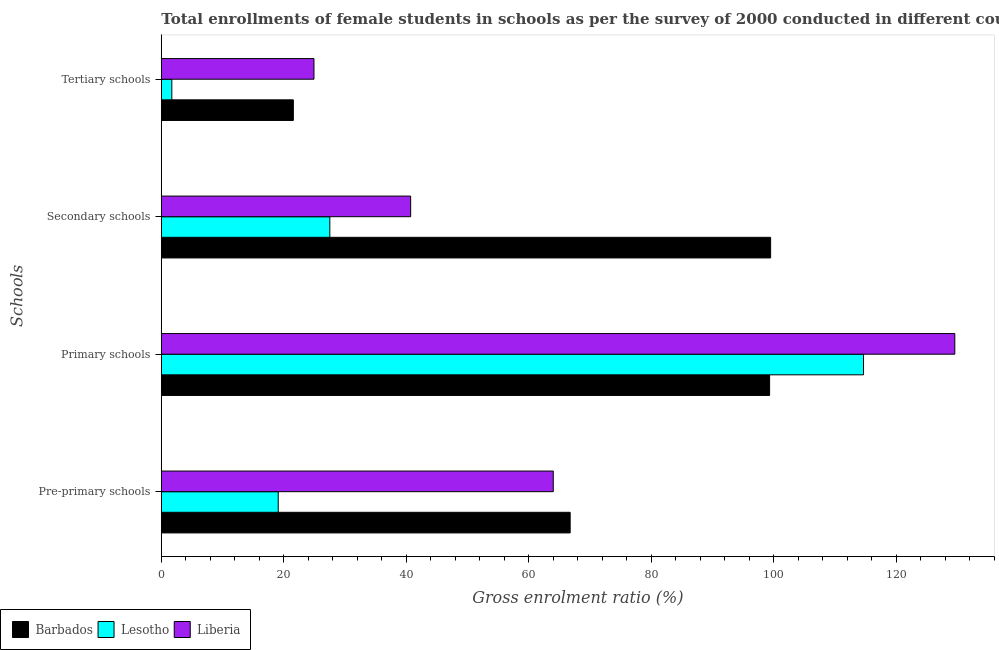How many groups of bars are there?
Make the answer very short. 4. Are the number of bars per tick equal to the number of legend labels?
Keep it short and to the point. Yes. How many bars are there on the 4th tick from the top?
Your answer should be compact. 3. How many bars are there on the 2nd tick from the bottom?
Your answer should be compact. 3. What is the label of the 2nd group of bars from the top?
Give a very brief answer. Secondary schools. What is the gross enrolment ratio(female) in primary schools in Lesotho?
Ensure brevity in your answer.  114.68. Across all countries, what is the maximum gross enrolment ratio(female) in primary schools?
Provide a short and direct response. 129.6. Across all countries, what is the minimum gross enrolment ratio(female) in primary schools?
Provide a succinct answer. 99.35. In which country was the gross enrolment ratio(female) in primary schools maximum?
Ensure brevity in your answer.  Liberia. In which country was the gross enrolment ratio(female) in secondary schools minimum?
Your answer should be very brief. Lesotho. What is the total gross enrolment ratio(female) in tertiary schools in the graph?
Your response must be concise. 48.21. What is the difference between the gross enrolment ratio(female) in secondary schools in Lesotho and that in Barbados?
Offer a terse response. -71.99. What is the difference between the gross enrolment ratio(female) in tertiary schools in Barbados and the gross enrolment ratio(female) in pre-primary schools in Liberia?
Provide a succinct answer. -42.45. What is the average gross enrolment ratio(female) in tertiary schools per country?
Your response must be concise. 16.07. What is the difference between the gross enrolment ratio(female) in pre-primary schools and gross enrolment ratio(female) in primary schools in Barbados?
Offer a terse response. -32.58. What is the ratio of the gross enrolment ratio(female) in secondary schools in Barbados to that in Lesotho?
Offer a terse response. 3.62. What is the difference between the highest and the second highest gross enrolment ratio(female) in primary schools?
Ensure brevity in your answer.  14.91. What is the difference between the highest and the lowest gross enrolment ratio(female) in secondary schools?
Your response must be concise. 71.99. In how many countries, is the gross enrolment ratio(female) in tertiary schools greater than the average gross enrolment ratio(female) in tertiary schools taken over all countries?
Give a very brief answer. 2. What does the 2nd bar from the top in Tertiary schools represents?
Offer a terse response. Lesotho. What does the 2nd bar from the bottom in Secondary schools represents?
Your answer should be compact. Lesotho. What is the difference between two consecutive major ticks on the X-axis?
Provide a succinct answer. 20. Are the values on the major ticks of X-axis written in scientific E-notation?
Keep it short and to the point. No. Does the graph contain any zero values?
Your response must be concise. No. What is the title of the graph?
Offer a terse response. Total enrollments of female students in schools as per the survey of 2000 conducted in different countries. Does "Luxembourg" appear as one of the legend labels in the graph?
Offer a very short reply. No. What is the label or title of the Y-axis?
Offer a terse response. Schools. What is the Gross enrolment ratio (%) in Barbados in Pre-primary schools?
Make the answer very short. 66.77. What is the Gross enrolment ratio (%) of Lesotho in Pre-primary schools?
Offer a very short reply. 19.09. What is the Gross enrolment ratio (%) in Liberia in Pre-primary schools?
Provide a succinct answer. 64.01. What is the Gross enrolment ratio (%) of Barbados in Primary schools?
Provide a short and direct response. 99.35. What is the Gross enrolment ratio (%) of Lesotho in Primary schools?
Offer a very short reply. 114.68. What is the Gross enrolment ratio (%) in Liberia in Primary schools?
Offer a very short reply. 129.6. What is the Gross enrolment ratio (%) in Barbados in Secondary schools?
Offer a very short reply. 99.51. What is the Gross enrolment ratio (%) of Lesotho in Secondary schools?
Keep it short and to the point. 27.52. What is the Gross enrolment ratio (%) of Liberia in Secondary schools?
Offer a terse response. 40.72. What is the Gross enrolment ratio (%) in Barbados in Tertiary schools?
Offer a terse response. 21.56. What is the Gross enrolment ratio (%) of Lesotho in Tertiary schools?
Give a very brief answer. 1.72. What is the Gross enrolment ratio (%) in Liberia in Tertiary schools?
Your response must be concise. 24.93. Across all Schools, what is the maximum Gross enrolment ratio (%) in Barbados?
Keep it short and to the point. 99.51. Across all Schools, what is the maximum Gross enrolment ratio (%) in Lesotho?
Your response must be concise. 114.68. Across all Schools, what is the maximum Gross enrolment ratio (%) of Liberia?
Provide a short and direct response. 129.6. Across all Schools, what is the minimum Gross enrolment ratio (%) in Barbados?
Ensure brevity in your answer.  21.56. Across all Schools, what is the minimum Gross enrolment ratio (%) of Lesotho?
Offer a terse response. 1.72. Across all Schools, what is the minimum Gross enrolment ratio (%) of Liberia?
Provide a succinct answer. 24.93. What is the total Gross enrolment ratio (%) of Barbados in the graph?
Offer a terse response. 287.2. What is the total Gross enrolment ratio (%) of Lesotho in the graph?
Provide a succinct answer. 163.02. What is the total Gross enrolment ratio (%) in Liberia in the graph?
Make the answer very short. 259.27. What is the difference between the Gross enrolment ratio (%) in Barbados in Pre-primary schools and that in Primary schools?
Give a very brief answer. -32.58. What is the difference between the Gross enrolment ratio (%) of Lesotho in Pre-primary schools and that in Primary schools?
Offer a very short reply. -95.59. What is the difference between the Gross enrolment ratio (%) of Liberia in Pre-primary schools and that in Primary schools?
Provide a short and direct response. -65.58. What is the difference between the Gross enrolment ratio (%) in Barbados in Pre-primary schools and that in Secondary schools?
Offer a very short reply. -32.74. What is the difference between the Gross enrolment ratio (%) of Lesotho in Pre-primary schools and that in Secondary schools?
Your response must be concise. -8.43. What is the difference between the Gross enrolment ratio (%) in Liberia in Pre-primary schools and that in Secondary schools?
Your answer should be compact. 23.29. What is the difference between the Gross enrolment ratio (%) of Barbados in Pre-primary schools and that in Tertiary schools?
Provide a succinct answer. 45.21. What is the difference between the Gross enrolment ratio (%) in Lesotho in Pre-primary schools and that in Tertiary schools?
Your response must be concise. 17.38. What is the difference between the Gross enrolment ratio (%) in Liberia in Pre-primary schools and that in Tertiary schools?
Provide a succinct answer. 39.08. What is the difference between the Gross enrolment ratio (%) in Barbados in Primary schools and that in Secondary schools?
Your answer should be very brief. -0.17. What is the difference between the Gross enrolment ratio (%) of Lesotho in Primary schools and that in Secondary schools?
Your answer should be very brief. 87.16. What is the difference between the Gross enrolment ratio (%) of Liberia in Primary schools and that in Secondary schools?
Keep it short and to the point. 88.87. What is the difference between the Gross enrolment ratio (%) of Barbados in Primary schools and that in Tertiary schools?
Offer a terse response. 77.78. What is the difference between the Gross enrolment ratio (%) of Lesotho in Primary schools and that in Tertiary schools?
Your answer should be very brief. 112.97. What is the difference between the Gross enrolment ratio (%) of Liberia in Primary schools and that in Tertiary schools?
Your answer should be compact. 104.66. What is the difference between the Gross enrolment ratio (%) of Barbados in Secondary schools and that in Tertiary schools?
Provide a short and direct response. 77.95. What is the difference between the Gross enrolment ratio (%) in Lesotho in Secondary schools and that in Tertiary schools?
Make the answer very short. 25.81. What is the difference between the Gross enrolment ratio (%) of Liberia in Secondary schools and that in Tertiary schools?
Keep it short and to the point. 15.79. What is the difference between the Gross enrolment ratio (%) of Barbados in Pre-primary schools and the Gross enrolment ratio (%) of Lesotho in Primary schools?
Keep it short and to the point. -47.91. What is the difference between the Gross enrolment ratio (%) of Barbados in Pre-primary schools and the Gross enrolment ratio (%) of Liberia in Primary schools?
Your answer should be very brief. -62.82. What is the difference between the Gross enrolment ratio (%) of Lesotho in Pre-primary schools and the Gross enrolment ratio (%) of Liberia in Primary schools?
Your answer should be very brief. -110.5. What is the difference between the Gross enrolment ratio (%) in Barbados in Pre-primary schools and the Gross enrolment ratio (%) in Lesotho in Secondary schools?
Give a very brief answer. 39.25. What is the difference between the Gross enrolment ratio (%) in Barbados in Pre-primary schools and the Gross enrolment ratio (%) in Liberia in Secondary schools?
Give a very brief answer. 26.05. What is the difference between the Gross enrolment ratio (%) of Lesotho in Pre-primary schools and the Gross enrolment ratio (%) of Liberia in Secondary schools?
Provide a succinct answer. -21.63. What is the difference between the Gross enrolment ratio (%) in Barbados in Pre-primary schools and the Gross enrolment ratio (%) in Lesotho in Tertiary schools?
Ensure brevity in your answer.  65.06. What is the difference between the Gross enrolment ratio (%) in Barbados in Pre-primary schools and the Gross enrolment ratio (%) in Liberia in Tertiary schools?
Give a very brief answer. 41.84. What is the difference between the Gross enrolment ratio (%) in Lesotho in Pre-primary schools and the Gross enrolment ratio (%) in Liberia in Tertiary schools?
Offer a very short reply. -5.84. What is the difference between the Gross enrolment ratio (%) of Barbados in Primary schools and the Gross enrolment ratio (%) of Lesotho in Secondary schools?
Keep it short and to the point. 71.83. What is the difference between the Gross enrolment ratio (%) of Barbados in Primary schools and the Gross enrolment ratio (%) of Liberia in Secondary schools?
Make the answer very short. 58.63. What is the difference between the Gross enrolment ratio (%) of Lesotho in Primary schools and the Gross enrolment ratio (%) of Liberia in Secondary schools?
Your answer should be very brief. 73.96. What is the difference between the Gross enrolment ratio (%) of Barbados in Primary schools and the Gross enrolment ratio (%) of Lesotho in Tertiary schools?
Provide a succinct answer. 97.63. What is the difference between the Gross enrolment ratio (%) of Barbados in Primary schools and the Gross enrolment ratio (%) of Liberia in Tertiary schools?
Provide a short and direct response. 74.42. What is the difference between the Gross enrolment ratio (%) in Lesotho in Primary schools and the Gross enrolment ratio (%) in Liberia in Tertiary schools?
Provide a succinct answer. 89.75. What is the difference between the Gross enrolment ratio (%) of Barbados in Secondary schools and the Gross enrolment ratio (%) of Lesotho in Tertiary schools?
Provide a succinct answer. 97.8. What is the difference between the Gross enrolment ratio (%) of Barbados in Secondary schools and the Gross enrolment ratio (%) of Liberia in Tertiary schools?
Give a very brief answer. 74.58. What is the difference between the Gross enrolment ratio (%) in Lesotho in Secondary schools and the Gross enrolment ratio (%) in Liberia in Tertiary schools?
Provide a succinct answer. 2.59. What is the average Gross enrolment ratio (%) of Barbados per Schools?
Give a very brief answer. 71.8. What is the average Gross enrolment ratio (%) in Lesotho per Schools?
Give a very brief answer. 40.75. What is the average Gross enrolment ratio (%) in Liberia per Schools?
Provide a succinct answer. 64.82. What is the difference between the Gross enrolment ratio (%) of Barbados and Gross enrolment ratio (%) of Lesotho in Pre-primary schools?
Offer a terse response. 47.68. What is the difference between the Gross enrolment ratio (%) of Barbados and Gross enrolment ratio (%) of Liberia in Pre-primary schools?
Offer a very short reply. 2.76. What is the difference between the Gross enrolment ratio (%) of Lesotho and Gross enrolment ratio (%) of Liberia in Pre-primary schools?
Provide a short and direct response. -44.92. What is the difference between the Gross enrolment ratio (%) of Barbados and Gross enrolment ratio (%) of Lesotho in Primary schools?
Your response must be concise. -15.34. What is the difference between the Gross enrolment ratio (%) of Barbados and Gross enrolment ratio (%) of Liberia in Primary schools?
Ensure brevity in your answer.  -30.25. What is the difference between the Gross enrolment ratio (%) of Lesotho and Gross enrolment ratio (%) of Liberia in Primary schools?
Offer a very short reply. -14.91. What is the difference between the Gross enrolment ratio (%) in Barbados and Gross enrolment ratio (%) in Lesotho in Secondary schools?
Provide a short and direct response. 71.99. What is the difference between the Gross enrolment ratio (%) of Barbados and Gross enrolment ratio (%) of Liberia in Secondary schools?
Provide a short and direct response. 58.79. What is the difference between the Gross enrolment ratio (%) in Lesotho and Gross enrolment ratio (%) in Liberia in Secondary schools?
Your answer should be very brief. -13.2. What is the difference between the Gross enrolment ratio (%) in Barbados and Gross enrolment ratio (%) in Lesotho in Tertiary schools?
Your response must be concise. 19.85. What is the difference between the Gross enrolment ratio (%) of Barbados and Gross enrolment ratio (%) of Liberia in Tertiary schools?
Offer a very short reply. -3.37. What is the difference between the Gross enrolment ratio (%) in Lesotho and Gross enrolment ratio (%) in Liberia in Tertiary schools?
Your answer should be compact. -23.22. What is the ratio of the Gross enrolment ratio (%) in Barbados in Pre-primary schools to that in Primary schools?
Ensure brevity in your answer.  0.67. What is the ratio of the Gross enrolment ratio (%) of Lesotho in Pre-primary schools to that in Primary schools?
Make the answer very short. 0.17. What is the ratio of the Gross enrolment ratio (%) of Liberia in Pre-primary schools to that in Primary schools?
Keep it short and to the point. 0.49. What is the ratio of the Gross enrolment ratio (%) in Barbados in Pre-primary schools to that in Secondary schools?
Ensure brevity in your answer.  0.67. What is the ratio of the Gross enrolment ratio (%) in Lesotho in Pre-primary schools to that in Secondary schools?
Provide a short and direct response. 0.69. What is the ratio of the Gross enrolment ratio (%) of Liberia in Pre-primary schools to that in Secondary schools?
Offer a very short reply. 1.57. What is the ratio of the Gross enrolment ratio (%) of Barbados in Pre-primary schools to that in Tertiary schools?
Provide a short and direct response. 3.1. What is the ratio of the Gross enrolment ratio (%) of Lesotho in Pre-primary schools to that in Tertiary schools?
Offer a very short reply. 11.12. What is the ratio of the Gross enrolment ratio (%) in Liberia in Pre-primary schools to that in Tertiary schools?
Your answer should be very brief. 2.57. What is the ratio of the Gross enrolment ratio (%) of Lesotho in Primary schools to that in Secondary schools?
Your response must be concise. 4.17. What is the ratio of the Gross enrolment ratio (%) in Liberia in Primary schools to that in Secondary schools?
Provide a succinct answer. 3.18. What is the ratio of the Gross enrolment ratio (%) in Barbados in Primary schools to that in Tertiary schools?
Give a very brief answer. 4.61. What is the ratio of the Gross enrolment ratio (%) in Lesotho in Primary schools to that in Tertiary schools?
Provide a succinct answer. 66.79. What is the ratio of the Gross enrolment ratio (%) of Liberia in Primary schools to that in Tertiary schools?
Provide a short and direct response. 5.2. What is the ratio of the Gross enrolment ratio (%) of Barbados in Secondary schools to that in Tertiary schools?
Your answer should be compact. 4.61. What is the ratio of the Gross enrolment ratio (%) in Lesotho in Secondary schools to that in Tertiary schools?
Offer a very short reply. 16.03. What is the ratio of the Gross enrolment ratio (%) of Liberia in Secondary schools to that in Tertiary schools?
Keep it short and to the point. 1.63. What is the difference between the highest and the second highest Gross enrolment ratio (%) in Barbados?
Keep it short and to the point. 0.17. What is the difference between the highest and the second highest Gross enrolment ratio (%) in Lesotho?
Make the answer very short. 87.16. What is the difference between the highest and the second highest Gross enrolment ratio (%) of Liberia?
Provide a succinct answer. 65.58. What is the difference between the highest and the lowest Gross enrolment ratio (%) of Barbados?
Ensure brevity in your answer.  77.95. What is the difference between the highest and the lowest Gross enrolment ratio (%) of Lesotho?
Give a very brief answer. 112.97. What is the difference between the highest and the lowest Gross enrolment ratio (%) of Liberia?
Offer a terse response. 104.66. 